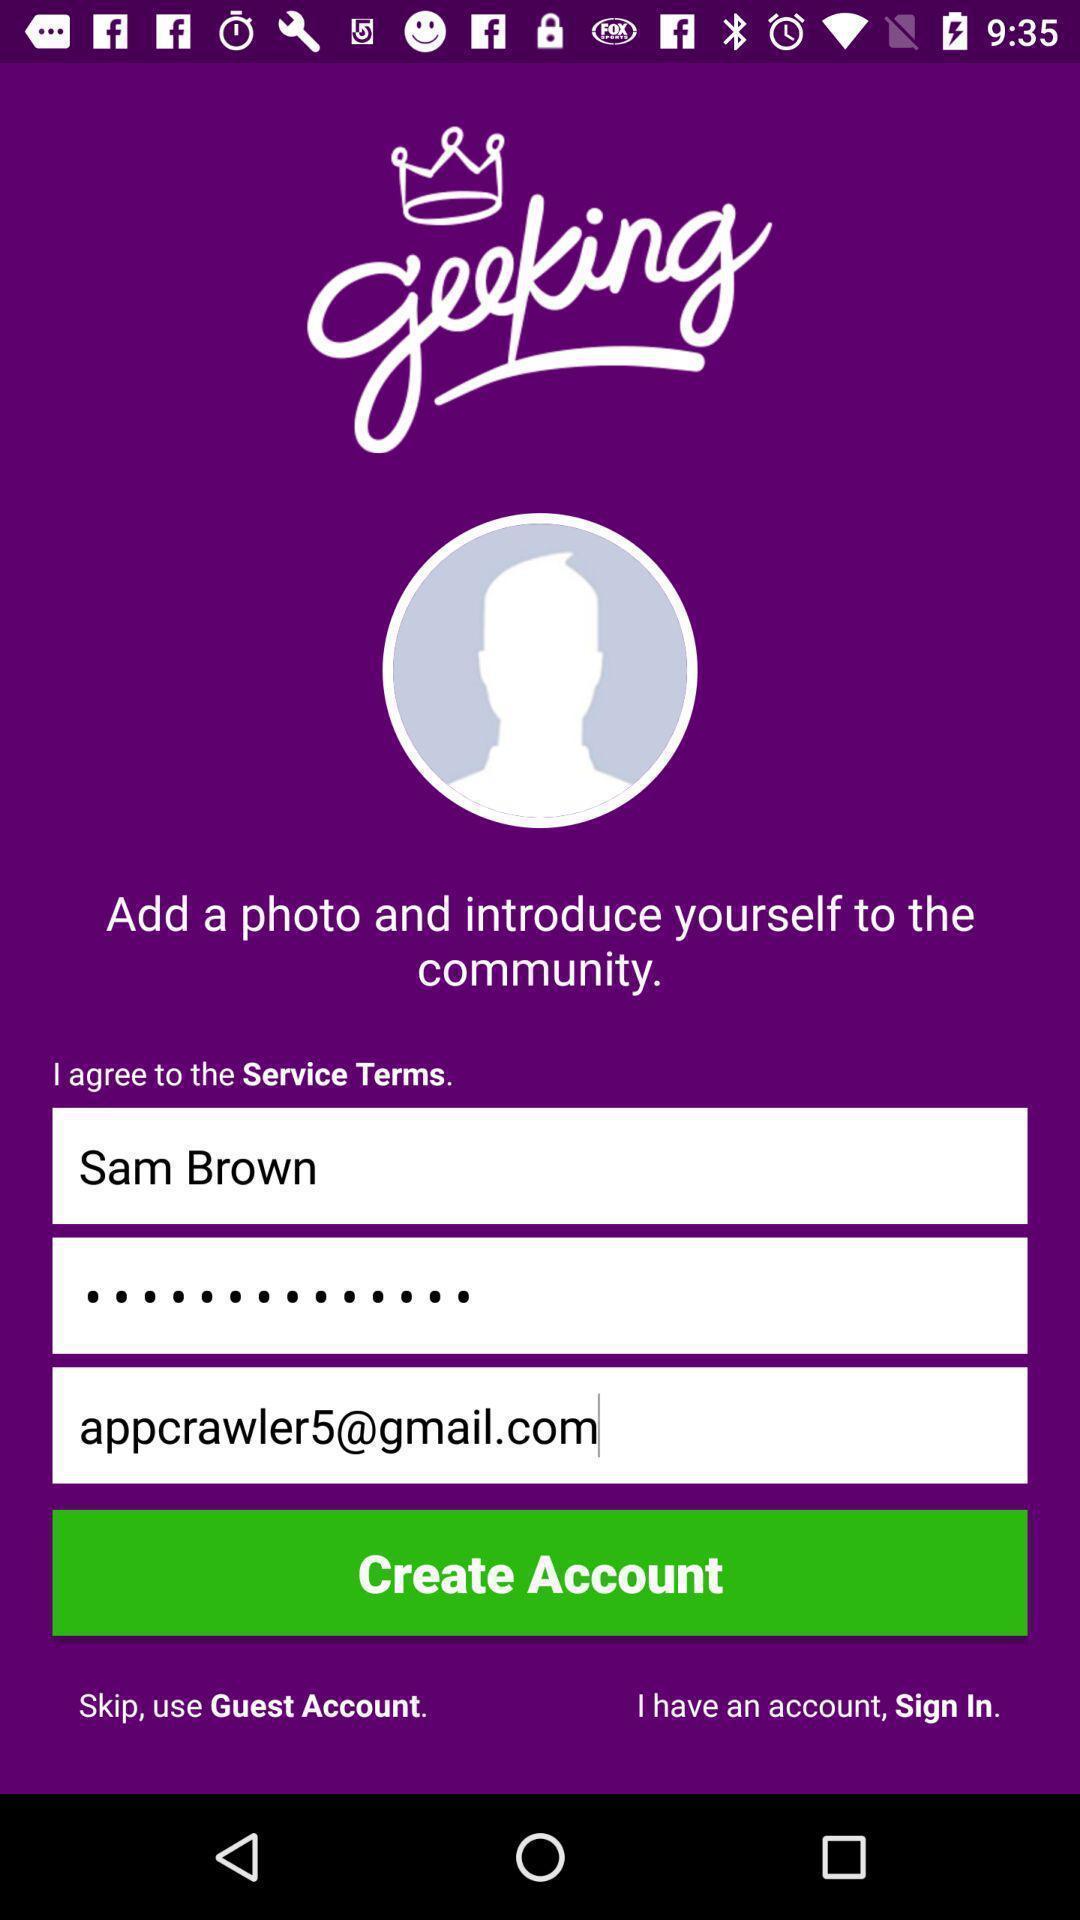Provide a textual representation of this image. Sign up/ sign in page for a community application. 